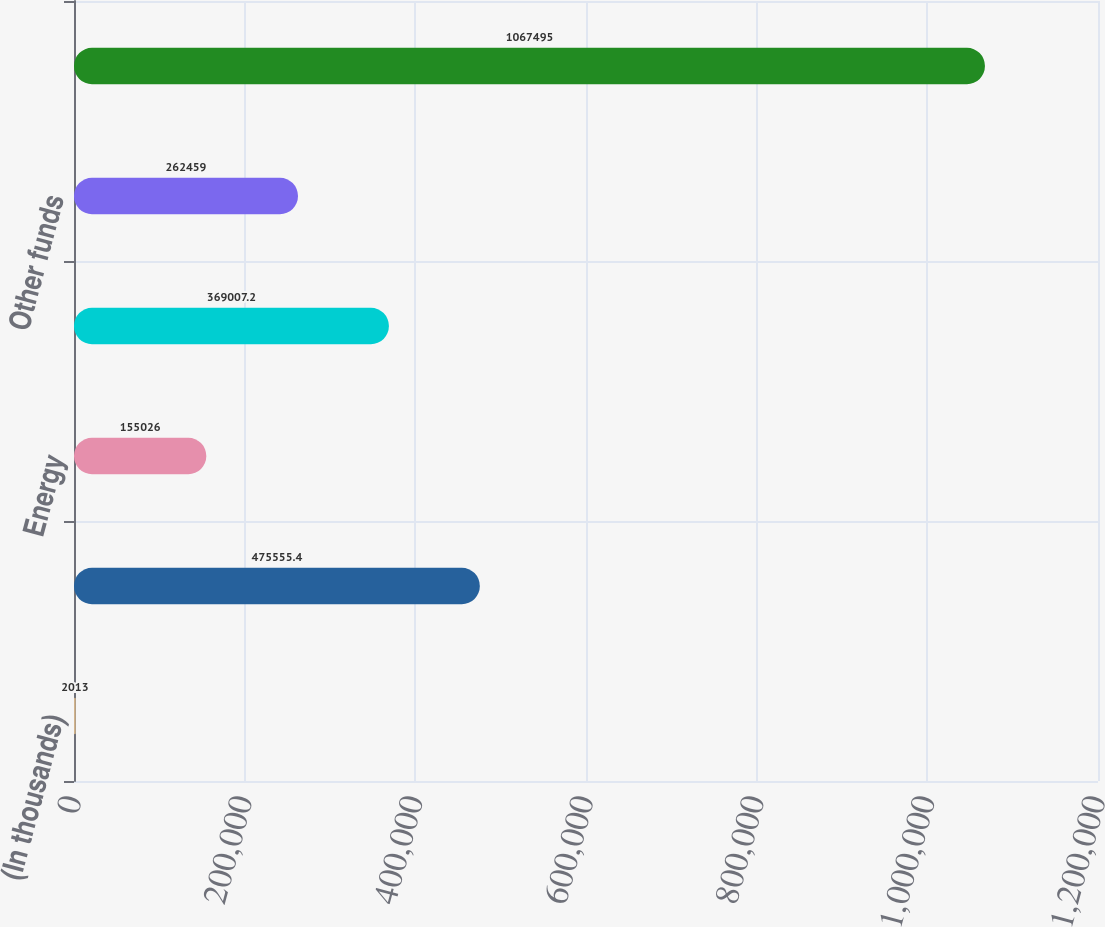<chart> <loc_0><loc_0><loc_500><loc_500><bar_chart><fcel>(In thousands)<fcel>Real estate<fcel>Energy<fcel>Hedged equity<fcel>Other funds<fcel>Total<nl><fcel>2013<fcel>475555<fcel>155026<fcel>369007<fcel>262459<fcel>1.0675e+06<nl></chart> 